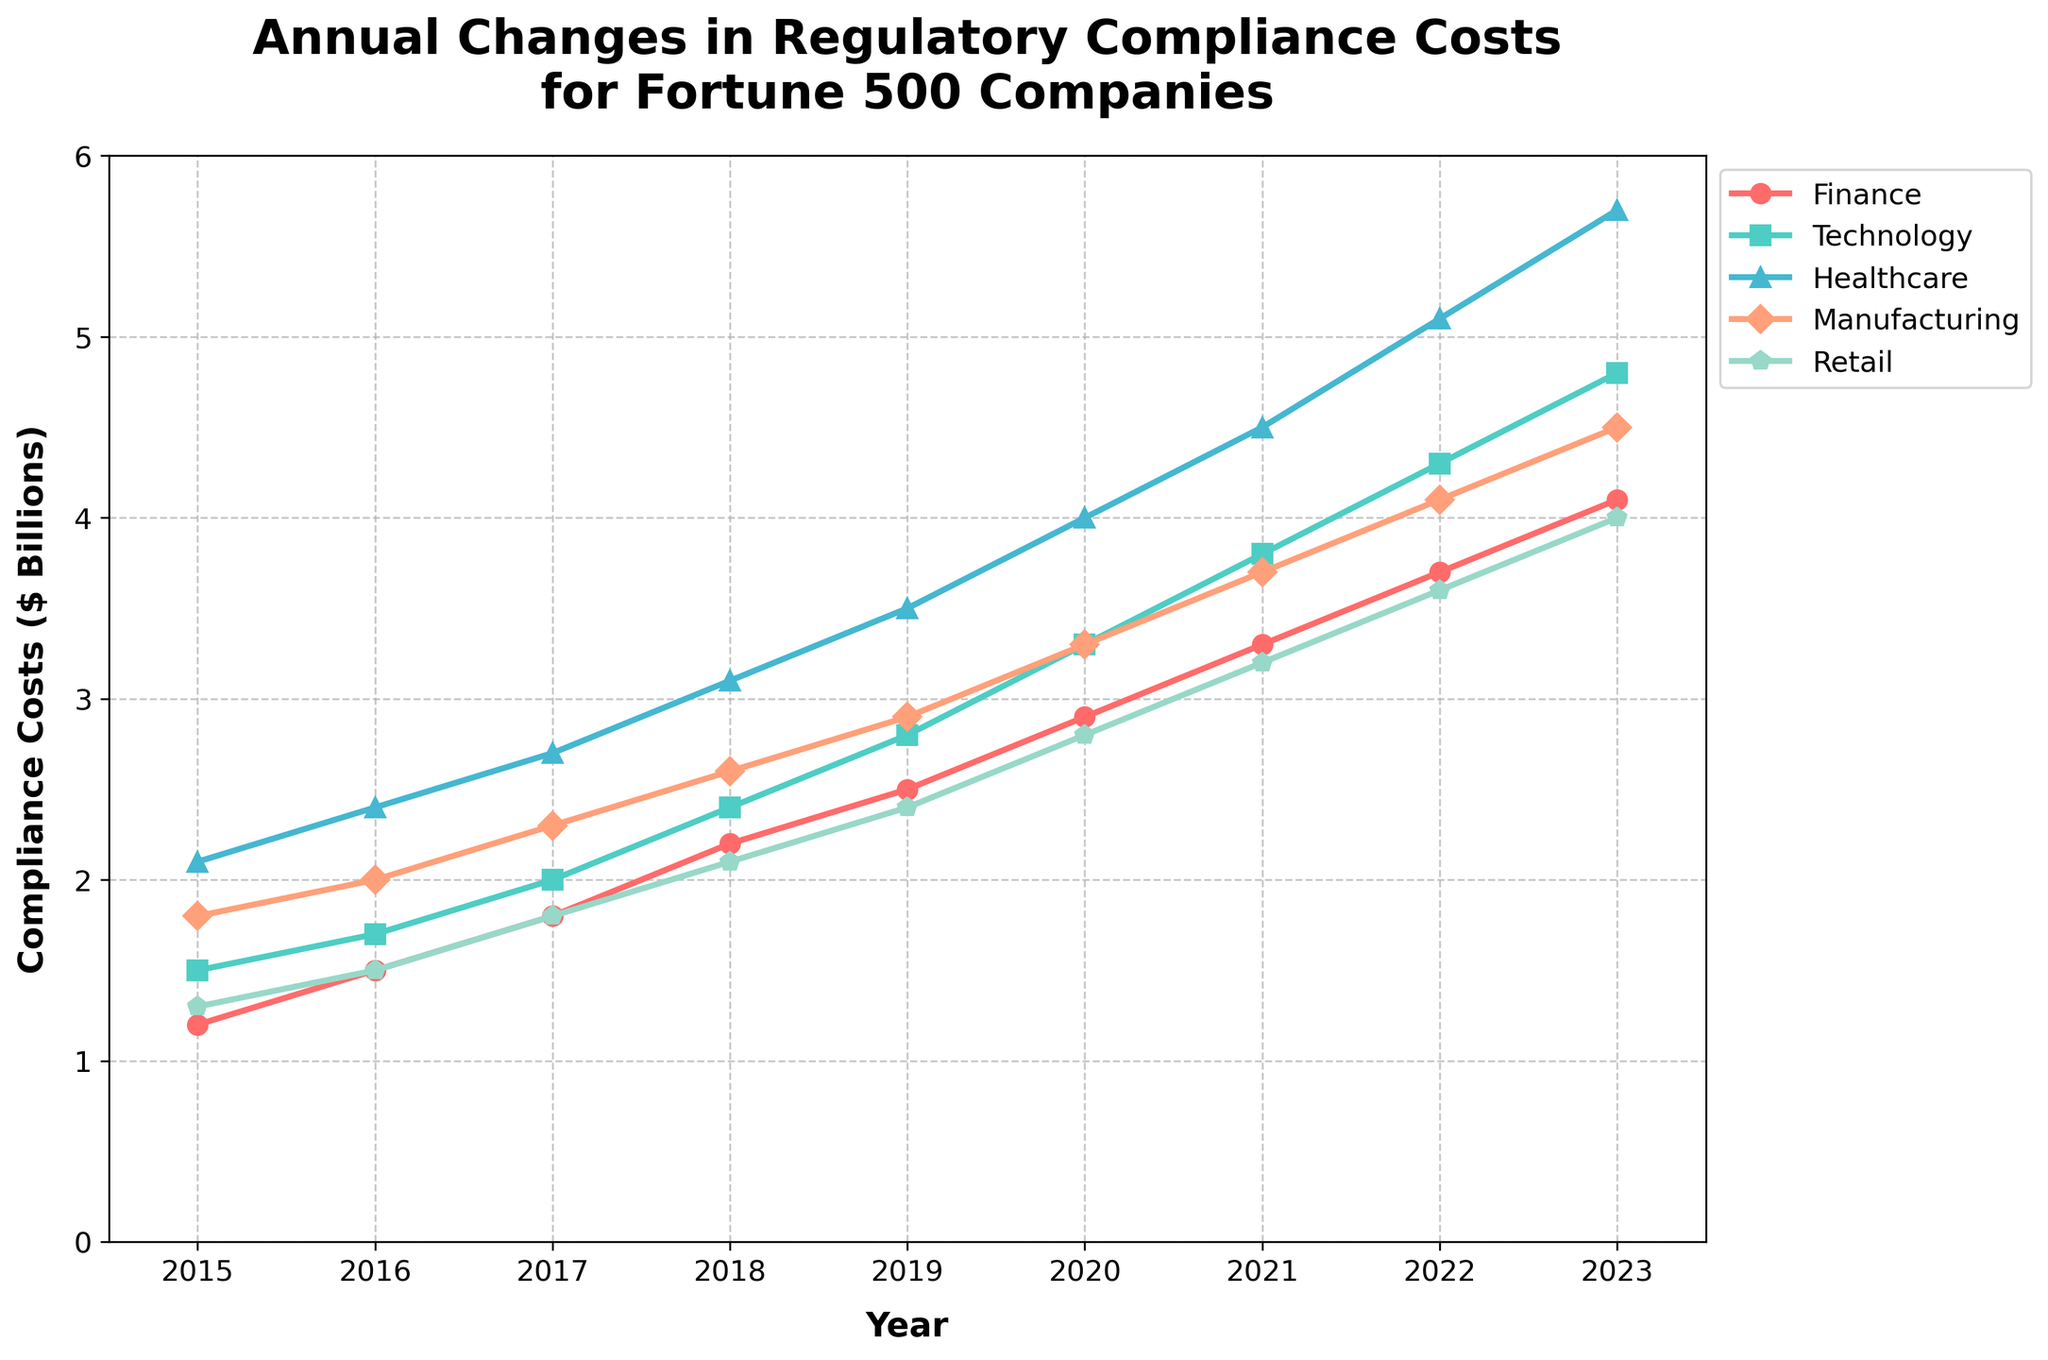What's the trend in healthcare compliance costs from 2015 to 2023? The healthcare compliance costs increase each year, starting at 2.1 billion dollars in 2015 and rising to 5.7 billion dollars in 2023.
Answer: Rising Which business area had the highest compliance costs in 2020? In 2020, healthcare had the highest compliance costs, as the value for healthcare (4.0 billion dollars) is higher than the values for all other business areas.
Answer: Healthcare In which year did retail compliance costs reach 3.6 billion dollars? By examining the retail line, it intersects with the 3.6 billion dollars mark at the year 2022.
Answer: 2022 What is the difference in compliance costs between finance and technology in 2019? In 2019, finance compliance costs were 2.5 billion dollars and technology compliance costs were 2.8 billion dollars. The difference is 2.8 - 2.5 = 0.3 billion dollars.
Answer: 0.3 billion dollars Which business area showed the most consistent increase in compliance costs over the years? All business areas show an increasing trend, but finance seems to display the most consistent linear increase without large jumps or dips.
Answer: Finance What is the average compliance cost for manufacturing from 2015 to 2023? Sum the compliance costs for manufacturing from 2015 to 2023 (1.8, 2.0, 2.3, 2.6, 2.9, 3.3, 3.7, 4.1, 4.5) and then divide by the number of years (9). The average is (1.8+2.0+2.3+2.6+2.9+3.3+3.7+4.1+4.5)/9 = 3.02 billion dollars.
Answer: 3.02 billion dollars How many years did technology compliance costs exceed 3 billion dollars? Technology costs exceed 3 billion dollars in the years 2020 (3.3 billion dollars), 2021 (3.8 billion dollars), 2022 (4.3 billion dollars), and 2023 (4.8 billion dollars). This occurs in 4 years.
Answer: 4 years Compare the compliance costs for finance and retail in 2023 and identify which is higher. In 2023, the compliance costs for finance are 4.1 billion dollars, while for retail it is 4.0 billion dollars. Thus, finance compliance costs are slightly higher.
Answer: Finance In which year did manufacturing compliance costs first exceed 3 billion dollars? The manufacturing compliance costs first exceed 3 billion dollars in 2019, as indicated by the line crossing the 3 billion dollars mark.
Answer: 2019 Rank the business areas by their compliance costs in 2015, from highest to lowest. In 2015: Healthcare (2.1 billion dollars), Manufacturing (1.8 billion dollars), Technology (1.5 billion dollars), Retail (1.3 billion dollars), and Finance (1.2 billion dollars).
Answer: Healthcare > Manufacturing > Technology > Retail > Finance 